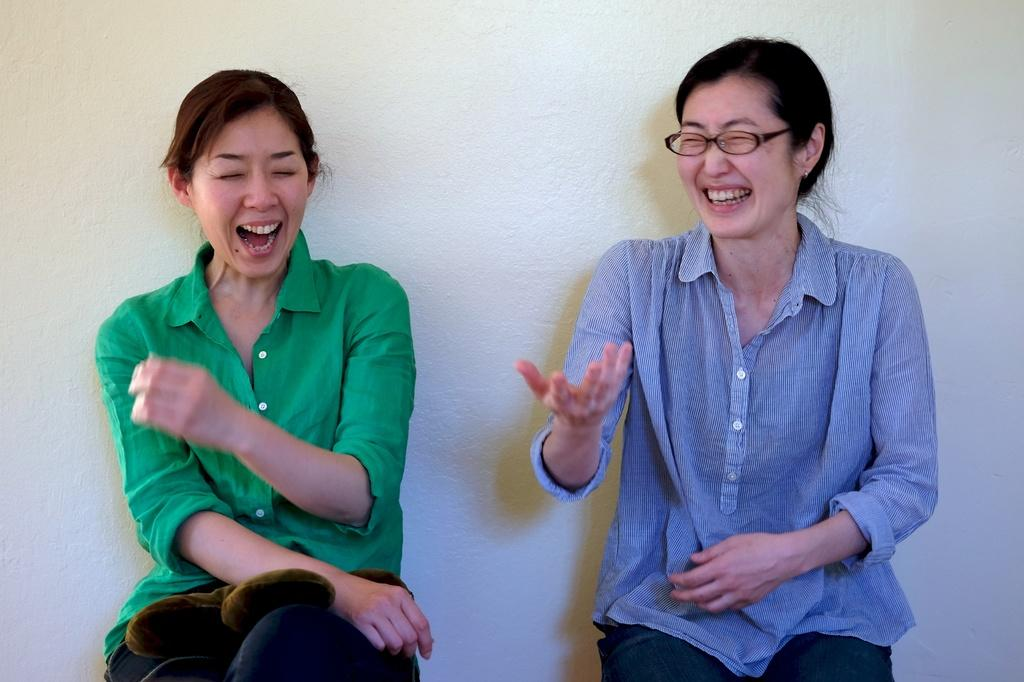What is the woman in the image wearing on her upper body? The woman is wearing a green shirt in the image. What can be seen on the woman's face? The woman is wearing spectacles and smiling. How many women are present in the image? There are two women in the image. What is the second woman wearing on her upper body? The second woman is wearing a blue shirt. What is the facial expression of the second woman? The second woman is also smiling. What is visible in the background of the image? There is a wall in the background of the image. What type of disgust can be seen on the women's faces in the image? There is no indication of disgust on the women's faces in the image; they are both smiling. Can you describe the seashore visible in the image? There is no seashore present in the image; it features two women and a wall in the background. 